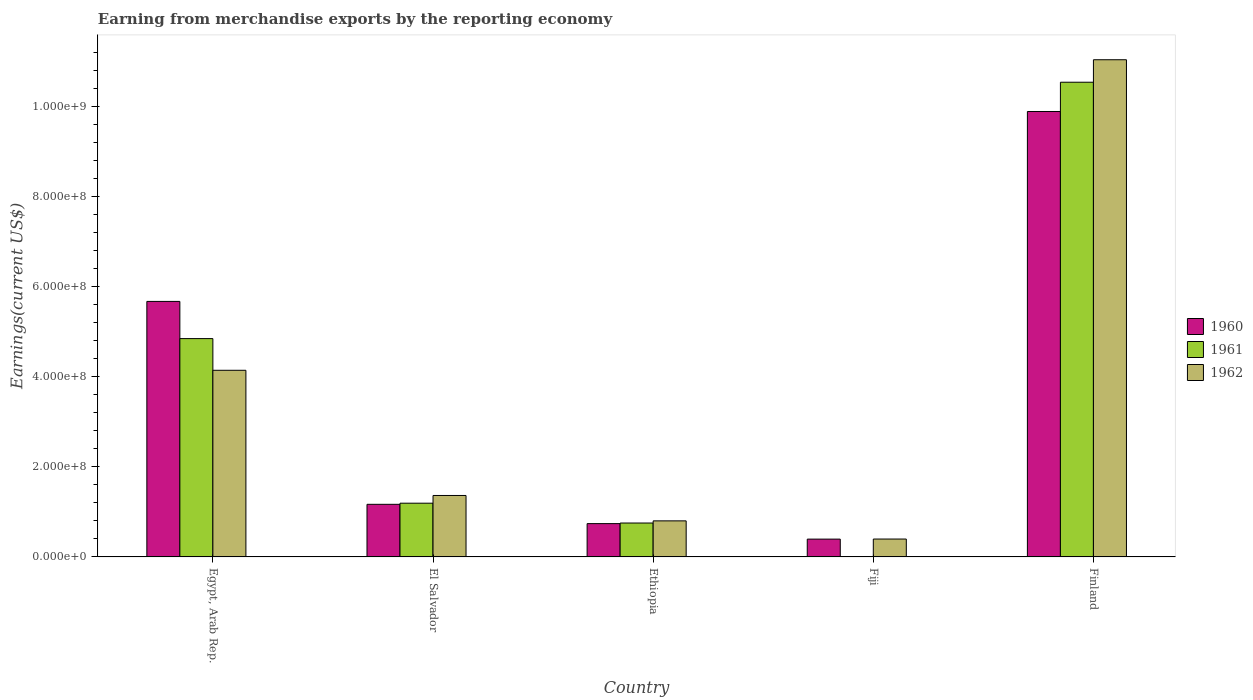How many different coloured bars are there?
Give a very brief answer. 3. Are the number of bars per tick equal to the number of legend labels?
Your answer should be compact. Yes. Are the number of bars on each tick of the X-axis equal?
Provide a short and direct response. Yes. How many bars are there on the 4th tick from the left?
Your answer should be compact. 3. How many bars are there on the 2nd tick from the right?
Make the answer very short. 3. What is the label of the 1st group of bars from the left?
Offer a terse response. Egypt, Arab Rep. In how many cases, is the number of bars for a given country not equal to the number of legend labels?
Keep it short and to the point. 0. What is the amount earned from merchandise exports in 1962 in El Salvador?
Your answer should be very brief. 1.36e+08. Across all countries, what is the maximum amount earned from merchandise exports in 1962?
Give a very brief answer. 1.10e+09. Across all countries, what is the minimum amount earned from merchandise exports in 1962?
Offer a terse response. 3.97e+07. In which country was the amount earned from merchandise exports in 1962 maximum?
Give a very brief answer. Finland. In which country was the amount earned from merchandise exports in 1960 minimum?
Offer a terse response. Fiji. What is the total amount earned from merchandise exports in 1960 in the graph?
Your answer should be compact. 1.78e+09. What is the difference between the amount earned from merchandise exports in 1961 in El Salvador and that in Fiji?
Ensure brevity in your answer.  1.19e+08. What is the difference between the amount earned from merchandise exports in 1961 in Finland and the amount earned from merchandise exports in 1962 in Egypt, Arab Rep.?
Ensure brevity in your answer.  6.39e+08. What is the average amount earned from merchandise exports in 1962 per country?
Your answer should be very brief. 3.55e+08. What is the difference between the amount earned from merchandise exports of/in 1961 and amount earned from merchandise exports of/in 1962 in Fiji?
Give a very brief answer. -3.95e+07. In how many countries, is the amount earned from merchandise exports in 1962 greater than 960000000 US$?
Offer a terse response. 1. What is the ratio of the amount earned from merchandise exports in 1960 in Egypt, Arab Rep. to that in Finland?
Ensure brevity in your answer.  0.57. Is the amount earned from merchandise exports in 1961 in Fiji less than that in Finland?
Offer a very short reply. Yes. What is the difference between the highest and the second highest amount earned from merchandise exports in 1961?
Your response must be concise. 9.34e+08. What is the difference between the highest and the lowest amount earned from merchandise exports in 1961?
Your answer should be very brief. 1.05e+09. In how many countries, is the amount earned from merchandise exports in 1960 greater than the average amount earned from merchandise exports in 1960 taken over all countries?
Make the answer very short. 2. Is the sum of the amount earned from merchandise exports in 1960 in Fiji and Finland greater than the maximum amount earned from merchandise exports in 1961 across all countries?
Ensure brevity in your answer.  No. Is it the case that in every country, the sum of the amount earned from merchandise exports in 1961 and amount earned from merchandise exports in 1960 is greater than the amount earned from merchandise exports in 1962?
Make the answer very short. No. How many bars are there?
Your answer should be compact. 15. What is the difference between two consecutive major ticks on the Y-axis?
Offer a terse response. 2.00e+08. Does the graph contain grids?
Your response must be concise. No. Where does the legend appear in the graph?
Give a very brief answer. Center right. How many legend labels are there?
Make the answer very short. 3. What is the title of the graph?
Your response must be concise. Earning from merchandise exports by the reporting economy. What is the label or title of the Y-axis?
Provide a succinct answer. Earnings(current US$). What is the Earnings(current US$) of 1960 in Egypt, Arab Rep.?
Make the answer very short. 5.67e+08. What is the Earnings(current US$) of 1961 in Egypt, Arab Rep.?
Provide a succinct answer. 4.84e+08. What is the Earnings(current US$) of 1962 in Egypt, Arab Rep.?
Make the answer very short. 4.14e+08. What is the Earnings(current US$) in 1960 in El Salvador?
Your response must be concise. 1.17e+08. What is the Earnings(current US$) of 1961 in El Salvador?
Offer a terse response. 1.19e+08. What is the Earnings(current US$) in 1962 in El Salvador?
Make the answer very short. 1.36e+08. What is the Earnings(current US$) of 1960 in Ethiopia?
Keep it short and to the point. 7.39e+07. What is the Earnings(current US$) in 1961 in Ethiopia?
Provide a succinct answer. 7.52e+07. What is the Earnings(current US$) in 1962 in Ethiopia?
Provide a short and direct response. 8.00e+07. What is the Earnings(current US$) of 1960 in Fiji?
Keep it short and to the point. 3.95e+07. What is the Earnings(current US$) of 1961 in Fiji?
Ensure brevity in your answer.  2.00e+05. What is the Earnings(current US$) of 1962 in Fiji?
Your response must be concise. 3.97e+07. What is the Earnings(current US$) in 1960 in Finland?
Provide a succinct answer. 9.88e+08. What is the Earnings(current US$) in 1961 in Finland?
Offer a very short reply. 1.05e+09. What is the Earnings(current US$) in 1962 in Finland?
Provide a succinct answer. 1.10e+09. Across all countries, what is the maximum Earnings(current US$) in 1960?
Make the answer very short. 9.88e+08. Across all countries, what is the maximum Earnings(current US$) in 1961?
Offer a terse response. 1.05e+09. Across all countries, what is the maximum Earnings(current US$) in 1962?
Your response must be concise. 1.10e+09. Across all countries, what is the minimum Earnings(current US$) of 1960?
Make the answer very short. 3.95e+07. Across all countries, what is the minimum Earnings(current US$) of 1961?
Keep it short and to the point. 2.00e+05. Across all countries, what is the minimum Earnings(current US$) in 1962?
Your answer should be very brief. 3.97e+07. What is the total Earnings(current US$) in 1960 in the graph?
Your response must be concise. 1.78e+09. What is the total Earnings(current US$) in 1961 in the graph?
Your answer should be very brief. 1.73e+09. What is the total Earnings(current US$) of 1962 in the graph?
Offer a very short reply. 1.77e+09. What is the difference between the Earnings(current US$) of 1960 in Egypt, Arab Rep. and that in El Salvador?
Ensure brevity in your answer.  4.50e+08. What is the difference between the Earnings(current US$) in 1961 in Egypt, Arab Rep. and that in El Salvador?
Ensure brevity in your answer.  3.65e+08. What is the difference between the Earnings(current US$) in 1962 in Egypt, Arab Rep. and that in El Salvador?
Your answer should be compact. 2.78e+08. What is the difference between the Earnings(current US$) in 1960 in Egypt, Arab Rep. and that in Ethiopia?
Provide a succinct answer. 4.93e+08. What is the difference between the Earnings(current US$) in 1961 in Egypt, Arab Rep. and that in Ethiopia?
Make the answer very short. 4.09e+08. What is the difference between the Earnings(current US$) in 1962 in Egypt, Arab Rep. and that in Ethiopia?
Your answer should be compact. 3.34e+08. What is the difference between the Earnings(current US$) in 1960 in Egypt, Arab Rep. and that in Fiji?
Provide a short and direct response. 5.27e+08. What is the difference between the Earnings(current US$) in 1961 in Egypt, Arab Rep. and that in Fiji?
Offer a terse response. 4.84e+08. What is the difference between the Earnings(current US$) of 1962 in Egypt, Arab Rep. and that in Fiji?
Your response must be concise. 3.74e+08. What is the difference between the Earnings(current US$) of 1960 in Egypt, Arab Rep. and that in Finland?
Make the answer very short. -4.21e+08. What is the difference between the Earnings(current US$) of 1961 in Egypt, Arab Rep. and that in Finland?
Offer a terse response. -5.69e+08. What is the difference between the Earnings(current US$) of 1962 in Egypt, Arab Rep. and that in Finland?
Ensure brevity in your answer.  -6.89e+08. What is the difference between the Earnings(current US$) of 1960 in El Salvador and that in Ethiopia?
Your answer should be compact. 4.28e+07. What is the difference between the Earnings(current US$) of 1961 in El Salvador and that in Ethiopia?
Offer a very short reply. 4.40e+07. What is the difference between the Earnings(current US$) of 1962 in El Salvador and that in Ethiopia?
Your response must be concise. 5.63e+07. What is the difference between the Earnings(current US$) in 1960 in El Salvador and that in Fiji?
Offer a very short reply. 7.72e+07. What is the difference between the Earnings(current US$) of 1961 in El Salvador and that in Fiji?
Keep it short and to the point. 1.19e+08. What is the difference between the Earnings(current US$) in 1962 in El Salvador and that in Fiji?
Provide a short and direct response. 9.66e+07. What is the difference between the Earnings(current US$) in 1960 in El Salvador and that in Finland?
Give a very brief answer. -8.71e+08. What is the difference between the Earnings(current US$) of 1961 in El Salvador and that in Finland?
Your answer should be compact. -9.34e+08. What is the difference between the Earnings(current US$) of 1962 in El Salvador and that in Finland?
Provide a succinct answer. -9.67e+08. What is the difference between the Earnings(current US$) in 1960 in Ethiopia and that in Fiji?
Your response must be concise. 3.44e+07. What is the difference between the Earnings(current US$) of 1961 in Ethiopia and that in Fiji?
Keep it short and to the point. 7.50e+07. What is the difference between the Earnings(current US$) in 1962 in Ethiopia and that in Fiji?
Your answer should be very brief. 4.03e+07. What is the difference between the Earnings(current US$) of 1960 in Ethiopia and that in Finland?
Offer a terse response. -9.14e+08. What is the difference between the Earnings(current US$) of 1961 in Ethiopia and that in Finland?
Provide a short and direct response. -9.78e+08. What is the difference between the Earnings(current US$) in 1962 in Ethiopia and that in Finland?
Keep it short and to the point. -1.02e+09. What is the difference between the Earnings(current US$) of 1960 in Fiji and that in Finland?
Offer a very short reply. -9.49e+08. What is the difference between the Earnings(current US$) of 1961 in Fiji and that in Finland?
Your answer should be compact. -1.05e+09. What is the difference between the Earnings(current US$) of 1962 in Fiji and that in Finland?
Your response must be concise. -1.06e+09. What is the difference between the Earnings(current US$) of 1960 in Egypt, Arab Rep. and the Earnings(current US$) of 1961 in El Salvador?
Keep it short and to the point. 4.48e+08. What is the difference between the Earnings(current US$) of 1960 in Egypt, Arab Rep. and the Earnings(current US$) of 1962 in El Salvador?
Keep it short and to the point. 4.30e+08. What is the difference between the Earnings(current US$) of 1961 in Egypt, Arab Rep. and the Earnings(current US$) of 1962 in El Salvador?
Your response must be concise. 3.48e+08. What is the difference between the Earnings(current US$) of 1960 in Egypt, Arab Rep. and the Earnings(current US$) of 1961 in Ethiopia?
Keep it short and to the point. 4.92e+08. What is the difference between the Earnings(current US$) of 1960 in Egypt, Arab Rep. and the Earnings(current US$) of 1962 in Ethiopia?
Give a very brief answer. 4.87e+08. What is the difference between the Earnings(current US$) of 1961 in Egypt, Arab Rep. and the Earnings(current US$) of 1962 in Ethiopia?
Make the answer very short. 4.04e+08. What is the difference between the Earnings(current US$) in 1960 in Egypt, Arab Rep. and the Earnings(current US$) in 1961 in Fiji?
Your response must be concise. 5.67e+08. What is the difference between the Earnings(current US$) of 1960 in Egypt, Arab Rep. and the Earnings(current US$) of 1962 in Fiji?
Your answer should be compact. 5.27e+08. What is the difference between the Earnings(current US$) of 1961 in Egypt, Arab Rep. and the Earnings(current US$) of 1962 in Fiji?
Provide a succinct answer. 4.45e+08. What is the difference between the Earnings(current US$) of 1960 in Egypt, Arab Rep. and the Earnings(current US$) of 1961 in Finland?
Provide a succinct answer. -4.86e+08. What is the difference between the Earnings(current US$) in 1960 in Egypt, Arab Rep. and the Earnings(current US$) in 1962 in Finland?
Give a very brief answer. -5.36e+08. What is the difference between the Earnings(current US$) in 1961 in Egypt, Arab Rep. and the Earnings(current US$) in 1962 in Finland?
Your answer should be compact. -6.19e+08. What is the difference between the Earnings(current US$) of 1960 in El Salvador and the Earnings(current US$) of 1961 in Ethiopia?
Keep it short and to the point. 4.15e+07. What is the difference between the Earnings(current US$) of 1960 in El Salvador and the Earnings(current US$) of 1962 in Ethiopia?
Make the answer very short. 3.67e+07. What is the difference between the Earnings(current US$) of 1961 in El Salvador and the Earnings(current US$) of 1962 in Ethiopia?
Keep it short and to the point. 3.92e+07. What is the difference between the Earnings(current US$) of 1960 in El Salvador and the Earnings(current US$) of 1961 in Fiji?
Ensure brevity in your answer.  1.16e+08. What is the difference between the Earnings(current US$) of 1960 in El Salvador and the Earnings(current US$) of 1962 in Fiji?
Make the answer very short. 7.70e+07. What is the difference between the Earnings(current US$) in 1961 in El Salvador and the Earnings(current US$) in 1962 in Fiji?
Offer a terse response. 7.95e+07. What is the difference between the Earnings(current US$) of 1960 in El Salvador and the Earnings(current US$) of 1961 in Finland?
Keep it short and to the point. -9.36e+08. What is the difference between the Earnings(current US$) in 1960 in El Salvador and the Earnings(current US$) in 1962 in Finland?
Provide a short and direct response. -9.86e+08. What is the difference between the Earnings(current US$) of 1961 in El Salvador and the Earnings(current US$) of 1962 in Finland?
Provide a short and direct response. -9.84e+08. What is the difference between the Earnings(current US$) in 1960 in Ethiopia and the Earnings(current US$) in 1961 in Fiji?
Give a very brief answer. 7.37e+07. What is the difference between the Earnings(current US$) of 1960 in Ethiopia and the Earnings(current US$) of 1962 in Fiji?
Your answer should be compact. 3.42e+07. What is the difference between the Earnings(current US$) of 1961 in Ethiopia and the Earnings(current US$) of 1962 in Fiji?
Provide a short and direct response. 3.55e+07. What is the difference between the Earnings(current US$) in 1960 in Ethiopia and the Earnings(current US$) in 1961 in Finland?
Your answer should be very brief. -9.79e+08. What is the difference between the Earnings(current US$) in 1960 in Ethiopia and the Earnings(current US$) in 1962 in Finland?
Offer a terse response. -1.03e+09. What is the difference between the Earnings(current US$) in 1961 in Ethiopia and the Earnings(current US$) in 1962 in Finland?
Offer a very short reply. -1.03e+09. What is the difference between the Earnings(current US$) in 1960 in Fiji and the Earnings(current US$) in 1961 in Finland?
Make the answer very short. -1.01e+09. What is the difference between the Earnings(current US$) in 1960 in Fiji and the Earnings(current US$) in 1962 in Finland?
Offer a very short reply. -1.06e+09. What is the difference between the Earnings(current US$) in 1961 in Fiji and the Earnings(current US$) in 1962 in Finland?
Offer a terse response. -1.10e+09. What is the average Earnings(current US$) of 1960 per country?
Provide a succinct answer. 3.57e+08. What is the average Earnings(current US$) of 1961 per country?
Offer a terse response. 3.46e+08. What is the average Earnings(current US$) of 1962 per country?
Your response must be concise. 3.55e+08. What is the difference between the Earnings(current US$) of 1960 and Earnings(current US$) of 1961 in Egypt, Arab Rep.?
Offer a terse response. 8.25e+07. What is the difference between the Earnings(current US$) of 1960 and Earnings(current US$) of 1962 in Egypt, Arab Rep.?
Give a very brief answer. 1.53e+08. What is the difference between the Earnings(current US$) of 1961 and Earnings(current US$) of 1962 in Egypt, Arab Rep.?
Ensure brevity in your answer.  7.03e+07. What is the difference between the Earnings(current US$) of 1960 and Earnings(current US$) of 1961 in El Salvador?
Offer a terse response. -2.50e+06. What is the difference between the Earnings(current US$) of 1960 and Earnings(current US$) of 1962 in El Salvador?
Offer a terse response. -1.96e+07. What is the difference between the Earnings(current US$) of 1961 and Earnings(current US$) of 1962 in El Salvador?
Offer a terse response. -1.71e+07. What is the difference between the Earnings(current US$) in 1960 and Earnings(current US$) in 1961 in Ethiopia?
Your answer should be very brief. -1.30e+06. What is the difference between the Earnings(current US$) of 1960 and Earnings(current US$) of 1962 in Ethiopia?
Offer a terse response. -6.10e+06. What is the difference between the Earnings(current US$) in 1961 and Earnings(current US$) in 1962 in Ethiopia?
Offer a very short reply. -4.80e+06. What is the difference between the Earnings(current US$) in 1960 and Earnings(current US$) in 1961 in Fiji?
Keep it short and to the point. 3.93e+07. What is the difference between the Earnings(current US$) in 1960 and Earnings(current US$) in 1962 in Fiji?
Your response must be concise. -2.00e+05. What is the difference between the Earnings(current US$) of 1961 and Earnings(current US$) of 1962 in Fiji?
Make the answer very short. -3.95e+07. What is the difference between the Earnings(current US$) of 1960 and Earnings(current US$) of 1961 in Finland?
Your response must be concise. -6.49e+07. What is the difference between the Earnings(current US$) in 1960 and Earnings(current US$) in 1962 in Finland?
Your answer should be very brief. -1.15e+08. What is the difference between the Earnings(current US$) of 1961 and Earnings(current US$) of 1962 in Finland?
Your answer should be compact. -4.99e+07. What is the ratio of the Earnings(current US$) in 1960 in Egypt, Arab Rep. to that in El Salvador?
Ensure brevity in your answer.  4.86. What is the ratio of the Earnings(current US$) in 1961 in Egypt, Arab Rep. to that in El Salvador?
Give a very brief answer. 4.06. What is the ratio of the Earnings(current US$) of 1962 in Egypt, Arab Rep. to that in El Salvador?
Your response must be concise. 3.04. What is the ratio of the Earnings(current US$) in 1960 in Egypt, Arab Rep. to that in Ethiopia?
Your answer should be compact. 7.67. What is the ratio of the Earnings(current US$) of 1961 in Egypt, Arab Rep. to that in Ethiopia?
Ensure brevity in your answer.  6.44. What is the ratio of the Earnings(current US$) of 1962 in Egypt, Arab Rep. to that in Ethiopia?
Provide a short and direct response. 5.17. What is the ratio of the Earnings(current US$) of 1960 in Egypt, Arab Rep. to that in Fiji?
Ensure brevity in your answer.  14.35. What is the ratio of the Earnings(current US$) of 1961 in Egypt, Arab Rep. to that in Fiji?
Provide a short and direct response. 2421.5. What is the ratio of the Earnings(current US$) in 1962 in Egypt, Arab Rep. to that in Fiji?
Offer a terse response. 10.43. What is the ratio of the Earnings(current US$) of 1960 in Egypt, Arab Rep. to that in Finland?
Provide a succinct answer. 0.57. What is the ratio of the Earnings(current US$) in 1961 in Egypt, Arab Rep. to that in Finland?
Make the answer very short. 0.46. What is the ratio of the Earnings(current US$) in 1962 in Egypt, Arab Rep. to that in Finland?
Your response must be concise. 0.38. What is the ratio of the Earnings(current US$) in 1960 in El Salvador to that in Ethiopia?
Offer a terse response. 1.58. What is the ratio of the Earnings(current US$) in 1961 in El Salvador to that in Ethiopia?
Keep it short and to the point. 1.59. What is the ratio of the Earnings(current US$) in 1962 in El Salvador to that in Ethiopia?
Offer a very short reply. 1.7. What is the ratio of the Earnings(current US$) in 1960 in El Salvador to that in Fiji?
Offer a terse response. 2.95. What is the ratio of the Earnings(current US$) of 1961 in El Salvador to that in Fiji?
Provide a succinct answer. 596. What is the ratio of the Earnings(current US$) of 1962 in El Salvador to that in Fiji?
Your response must be concise. 3.43. What is the ratio of the Earnings(current US$) of 1960 in El Salvador to that in Finland?
Keep it short and to the point. 0.12. What is the ratio of the Earnings(current US$) of 1961 in El Salvador to that in Finland?
Provide a succinct answer. 0.11. What is the ratio of the Earnings(current US$) in 1962 in El Salvador to that in Finland?
Offer a terse response. 0.12. What is the ratio of the Earnings(current US$) of 1960 in Ethiopia to that in Fiji?
Offer a very short reply. 1.87. What is the ratio of the Earnings(current US$) of 1961 in Ethiopia to that in Fiji?
Your response must be concise. 376. What is the ratio of the Earnings(current US$) in 1962 in Ethiopia to that in Fiji?
Your response must be concise. 2.02. What is the ratio of the Earnings(current US$) in 1960 in Ethiopia to that in Finland?
Give a very brief answer. 0.07. What is the ratio of the Earnings(current US$) in 1961 in Ethiopia to that in Finland?
Give a very brief answer. 0.07. What is the ratio of the Earnings(current US$) in 1962 in Ethiopia to that in Finland?
Your answer should be very brief. 0.07. What is the ratio of the Earnings(current US$) of 1962 in Fiji to that in Finland?
Give a very brief answer. 0.04. What is the difference between the highest and the second highest Earnings(current US$) of 1960?
Ensure brevity in your answer.  4.21e+08. What is the difference between the highest and the second highest Earnings(current US$) of 1961?
Ensure brevity in your answer.  5.69e+08. What is the difference between the highest and the second highest Earnings(current US$) in 1962?
Provide a succinct answer. 6.89e+08. What is the difference between the highest and the lowest Earnings(current US$) of 1960?
Your answer should be very brief. 9.49e+08. What is the difference between the highest and the lowest Earnings(current US$) of 1961?
Ensure brevity in your answer.  1.05e+09. What is the difference between the highest and the lowest Earnings(current US$) of 1962?
Make the answer very short. 1.06e+09. 